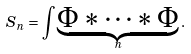Convert formula to latex. <formula><loc_0><loc_0><loc_500><loc_500>S _ { n } = \int \underbrace { \Phi * \cdots * \Phi } _ { n } .</formula> 